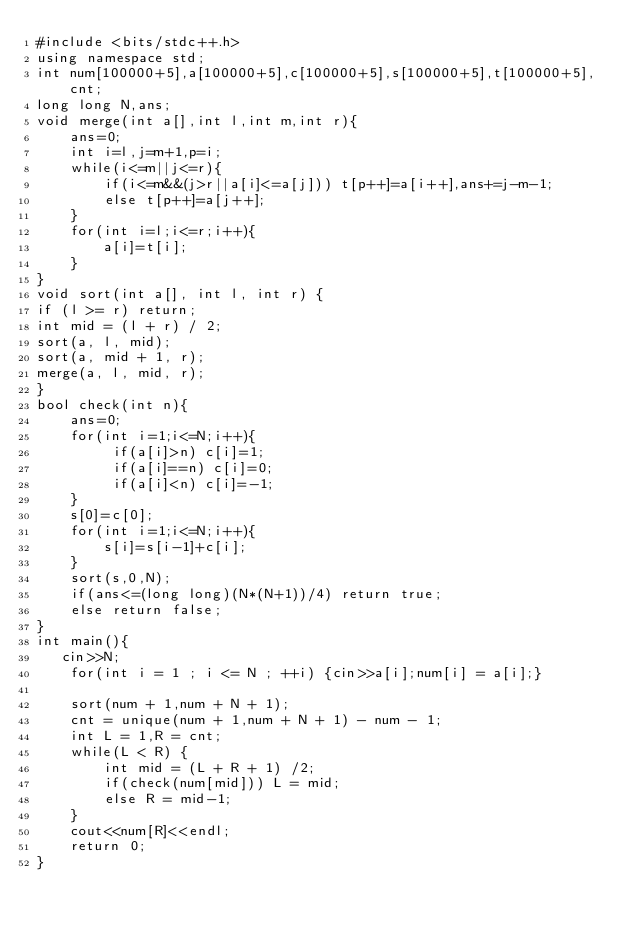<code> <loc_0><loc_0><loc_500><loc_500><_C++_>#include <bits/stdc++.h>
using namespace std;
int num[100000+5],a[100000+5],c[100000+5],s[100000+5],t[100000+5],cnt;
long long N,ans;
void merge(int a[],int l,int m,int r){
	ans=0;
	int i=l,j=m+1,p=i;
	while(i<=m||j<=r){
		if(i<=m&&(j>r||a[i]<=a[j])) t[p++]=a[i++],ans+=j-m-1;
		else t[p++]=a[j++];
	}
	for(int i=l;i<=r;i++){
		a[i]=t[i];
	}
}
void sort(int a[], int l, int r) {
if (l >= r) return;
int mid = (l + r) / 2;
sort(a, l, mid); 
sort(a, mid + 1, r); 
merge(a, l, mid, r);
}
bool check(int n){
	ans=0;
	for(int i=1;i<=N;i++){
	     if(a[i]>n) c[i]=1;
	     if(a[i]==n) c[i]=0;
		 if(a[i]<n) c[i]=-1;  	
	}
	s[0]=c[0];
	for(int i=1;i<=N;i++){
		s[i]=s[i-1]+c[i];
	}
	sort(s,0,N);
	if(ans<=(long long)(N*(N+1))/4) return true;
	else return false;
}
int main(){
   cin>>N;
    for(int i = 1 ; i <= N ; ++i) {cin>>a[i];num[i] = a[i];}
    
    sort(num + 1,num + N + 1);
    cnt = unique(num + 1,num + N + 1) - num - 1;
    int L = 1,R = cnt;
    while(L < R) {
        int mid = (L + R + 1) /2;
        if(check(num[mid])) L = mid;
        else R = mid-1;
    }
    cout<<num[R]<<endl;
    return 0;
}
</code> 